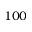<formula> <loc_0><loc_0><loc_500><loc_500>1 0 0</formula> 